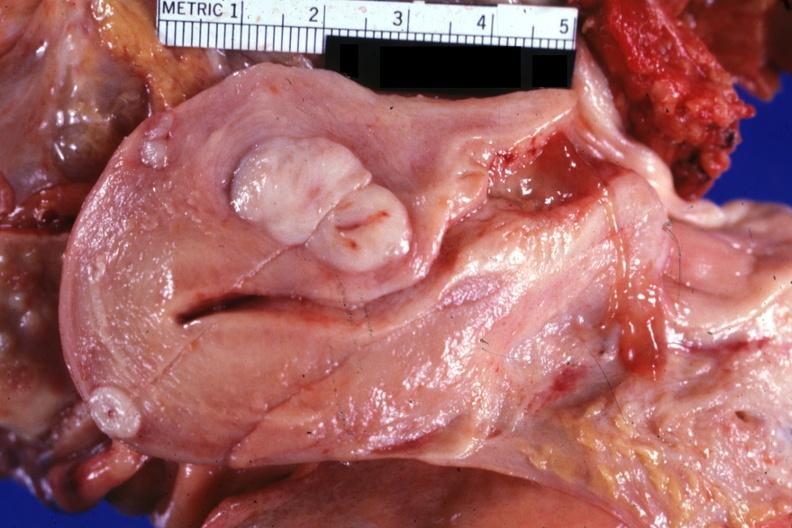does normal newborn show opened uterus with three myomas quite typical?
Answer the question using a single word or phrase. No 